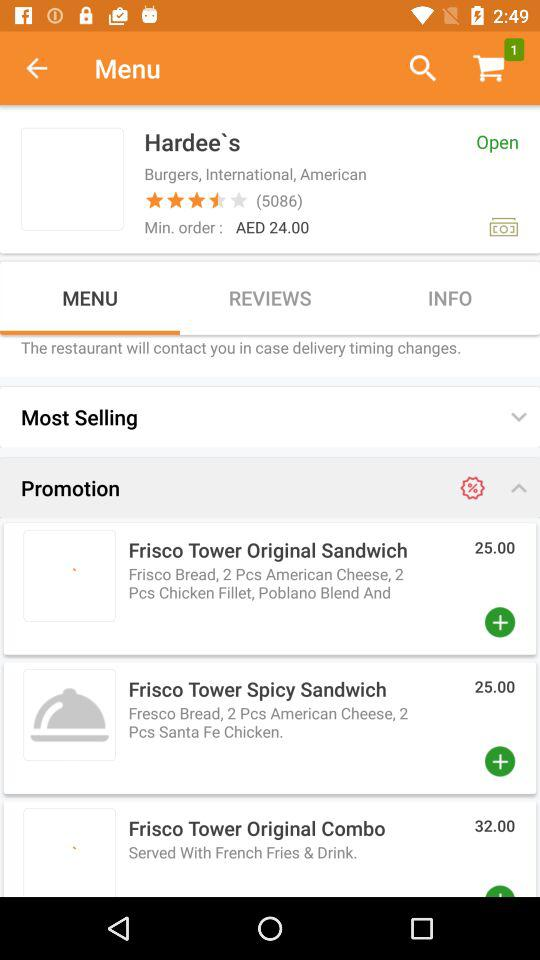What is the minimum order value that needs to be placed? The minimum order value that needs to be placed is AED 24. 